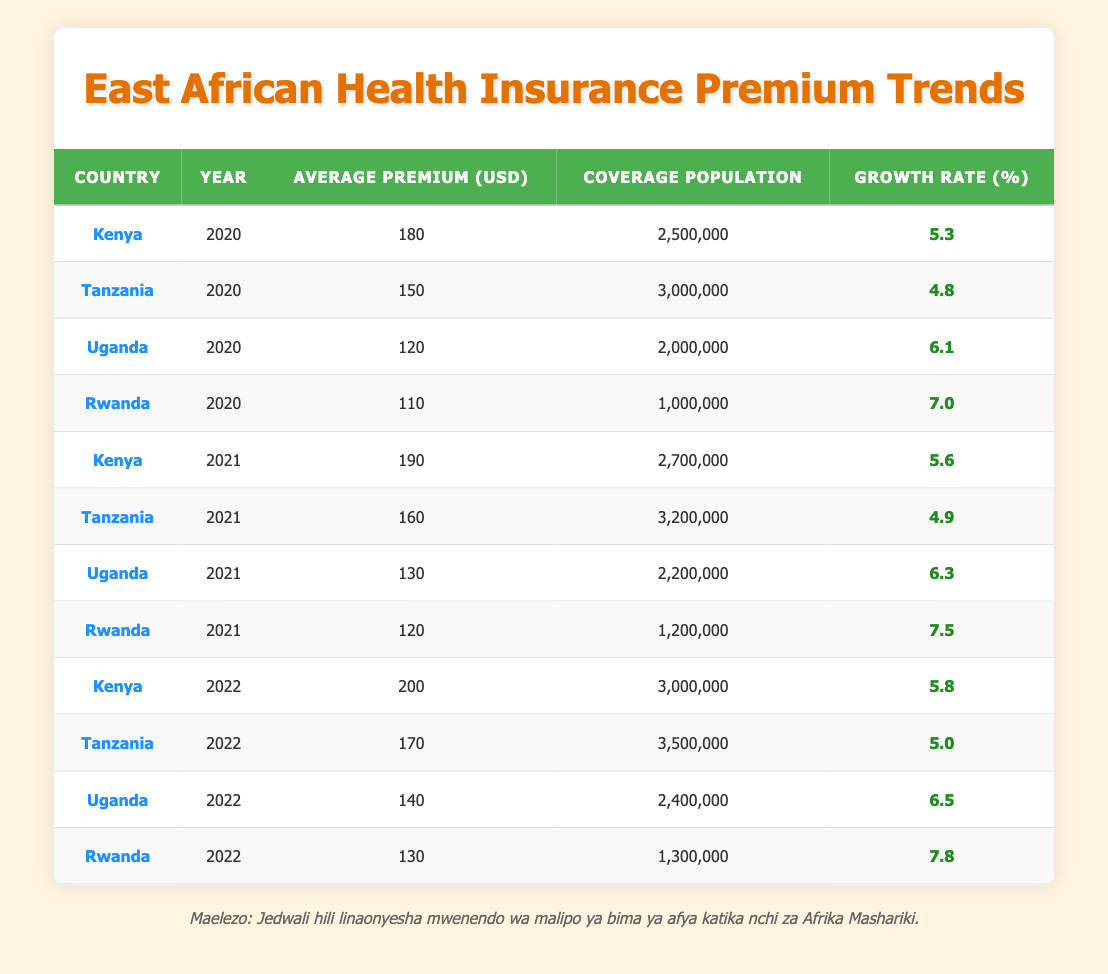What was the average premium in Uganda for the year 2021? Referring to the table, the average premium for Uganda in 2021 is listed as 130 USD.
Answer: 130 USD What is the growth rate of health insurance premiums in Rwanda for 2022? According to the table, the growth rate for Rwanda in 2022 is noted as 7.8%.
Answer: 7.8% Which country had the highest average premium in 2022? When comparing the average premiums for 2022 across the countries, Kenya had the highest at 200 USD.
Answer: Kenya What is the total coverage population in Tanzania for the years 2020, 2021, and 2022? The coverage populations for Tanzania are 3,000,000 (2020), 3,200,000 (2021), and 3,500,000 (2022). Adding these gives: 3,000,000 + 3,200,000 + 3,500,000 = 9,700,000.
Answer: 9,700,000 Did Uganda's average premium increase from 2020 to 2021? In 2020, Uganda's average premium was 120 USD, and in 2021 it rose to 130 USD. This indicates an increase.
Answer: Yes Which country showed the largest growth rate in 2021 compared to 2020? Comparing the growth rates from 2020 to 2021: Kenya (5.3% to 5.6%), Tanzania (4.8% to 4.9%), Uganda (6.1% to 6.3%), Rwanda (7.0% to 7.5%). The largest increase is for Rwanda, from 7.0% to 7.5%.
Answer: Rwanda What was the average premium for health coverage across all countries in 2020? The average premiums for 2020 were: Kenya (180), Tanzania (150), Uganda (120), Rwanda (110). Sum: 180 + 150 + 120 + 110 = 560, then divide by 4 countries, giving an average of 560 / 4 = 140 USD.
Answer: 140 USD Was the average premium in Kenya for 2021 higher than in Uganda for the same year? The average premium in Kenya for 2021 was 190 USD, and in Uganda, it was 130 USD. Since 190 is greater than 130, the statement is true.
Answer: Yes Which country consistently had the lowest average premium from 2020 to 2022? Looking at the premiums from each year, Rwanda had the lowest premium in each year: 110 (2020), 120 (2021), and 130 (2022) compared to others.
Answer: Rwanda 